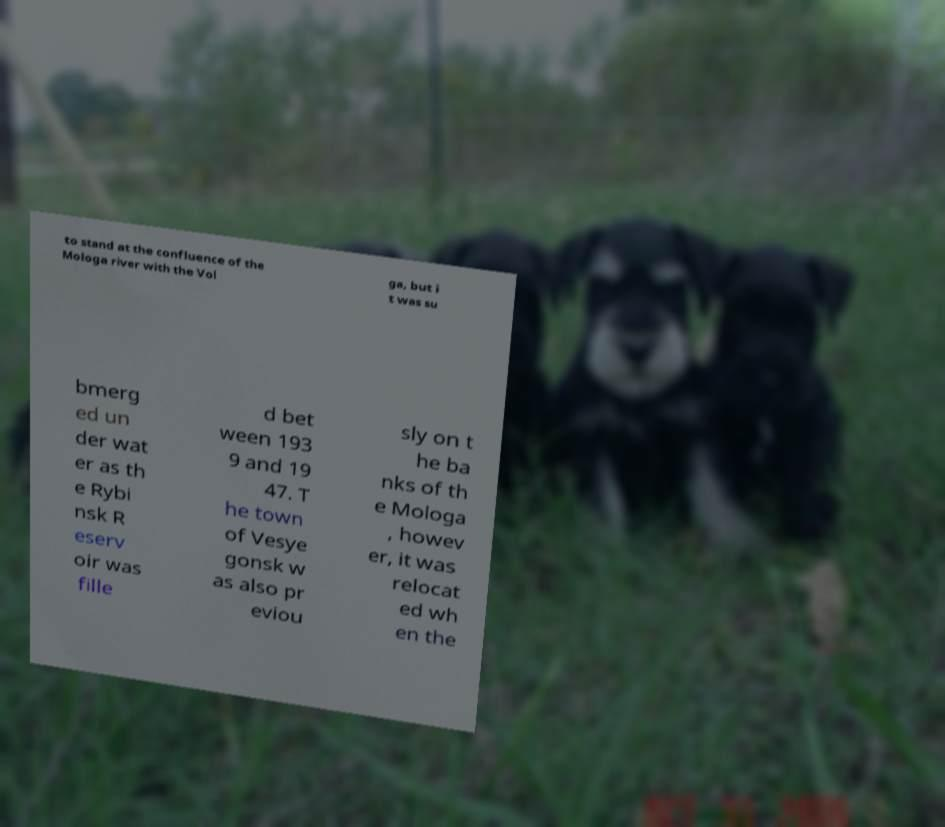Could you extract and type out the text from this image? to stand at the confluence of the Mologa river with the Vol ga, but i t was su bmerg ed un der wat er as th e Rybi nsk R eserv oir was fille d bet ween 193 9 and 19 47. T he town of Vesye gonsk w as also pr eviou sly on t he ba nks of th e Mologa , howev er, it was relocat ed wh en the 